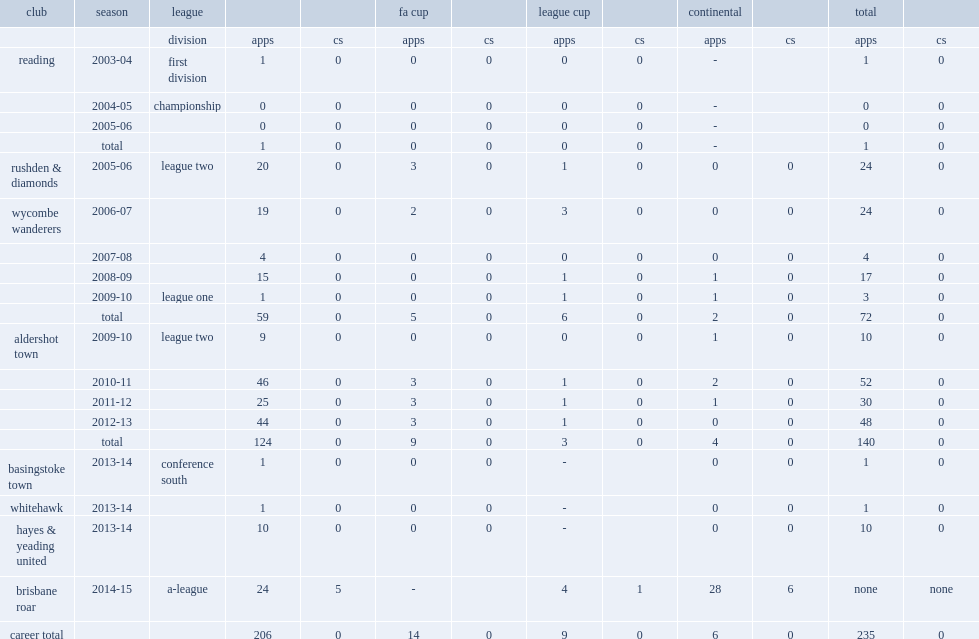Which club did young join in a-league club for the 2014-15 season? Brisbane roar. 